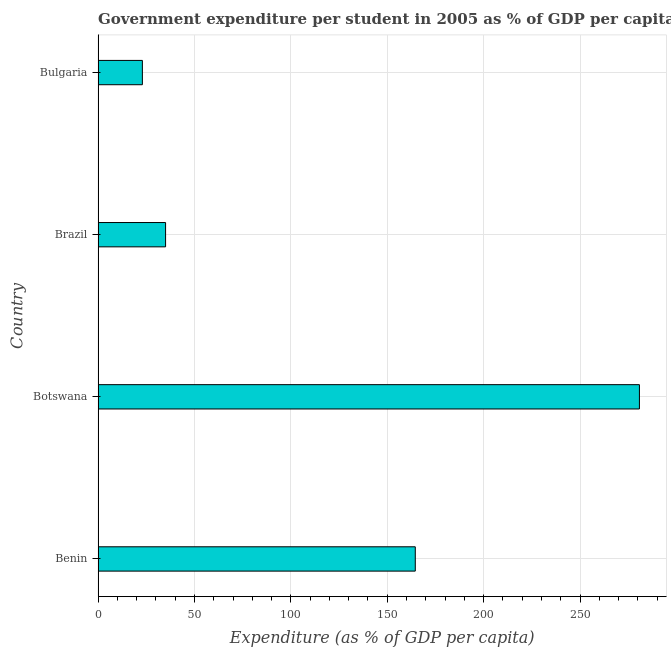Does the graph contain any zero values?
Provide a short and direct response. No. Does the graph contain grids?
Offer a terse response. Yes. What is the title of the graph?
Provide a short and direct response. Government expenditure per student in 2005 as % of GDP per capita in different ountries. What is the label or title of the X-axis?
Your response must be concise. Expenditure (as % of GDP per capita). What is the government expenditure per student in Bulgaria?
Your response must be concise. 22.97. Across all countries, what is the maximum government expenditure per student?
Keep it short and to the point. 280.81. Across all countries, what is the minimum government expenditure per student?
Provide a short and direct response. 22.97. In which country was the government expenditure per student maximum?
Provide a short and direct response. Botswana. In which country was the government expenditure per student minimum?
Provide a short and direct response. Bulgaria. What is the sum of the government expenditure per student?
Provide a short and direct response. 503.34. What is the difference between the government expenditure per student in Brazil and Bulgaria?
Keep it short and to the point. 12.04. What is the average government expenditure per student per country?
Keep it short and to the point. 125.83. What is the median government expenditure per student?
Offer a very short reply. 99.78. What is the ratio of the government expenditure per student in Botswana to that in Bulgaria?
Provide a succinct answer. 12.22. Is the government expenditure per student in Benin less than that in Botswana?
Keep it short and to the point. Yes. What is the difference between the highest and the second highest government expenditure per student?
Offer a terse response. 116.27. What is the difference between the highest and the lowest government expenditure per student?
Your response must be concise. 257.84. What is the difference between two consecutive major ticks on the X-axis?
Your response must be concise. 50. Are the values on the major ticks of X-axis written in scientific E-notation?
Make the answer very short. No. What is the Expenditure (as % of GDP per capita) in Benin?
Provide a short and direct response. 164.54. What is the Expenditure (as % of GDP per capita) of Botswana?
Provide a short and direct response. 280.81. What is the Expenditure (as % of GDP per capita) in Brazil?
Keep it short and to the point. 35.01. What is the Expenditure (as % of GDP per capita) in Bulgaria?
Keep it short and to the point. 22.97. What is the difference between the Expenditure (as % of GDP per capita) in Benin and Botswana?
Your response must be concise. -116.27. What is the difference between the Expenditure (as % of GDP per capita) in Benin and Brazil?
Offer a terse response. 129.53. What is the difference between the Expenditure (as % of GDP per capita) in Benin and Bulgaria?
Ensure brevity in your answer.  141.57. What is the difference between the Expenditure (as % of GDP per capita) in Botswana and Brazil?
Offer a very short reply. 245.8. What is the difference between the Expenditure (as % of GDP per capita) in Botswana and Bulgaria?
Offer a terse response. 257.84. What is the difference between the Expenditure (as % of GDP per capita) in Brazil and Bulgaria?
Make the answer very short. 12.04. What is the ratio of the Expenditure (as % of GDP per capita) in Benin to that in Botswana?
Ensure brevity in your answer.  0.59. What is the ratio of the Expenditure (as % of GDP per capita) in Benin to that in Brazil?
Your answer should be compact. 4.7. What is the ratio of the Expenditure (as % of GDP per capita) in Benin to that in Bulgaria?
Provide a short and direct response. 7.16. What is the ratio of the Expenditure (as % of GDP per capita) in Botswana to that in Brazil?
Provide a short and direct response. 8.02. What is the ratio of the Expenditure (as % of GDP per capita) in Botswana to that in Bulgaria?
Ensure brevity in your answer.  12.22. What is the ratio of the Expenditure (as % of GDP per capita) in Brazil to that in Bulgaria?
Your answer should be very brief. 1.52. 